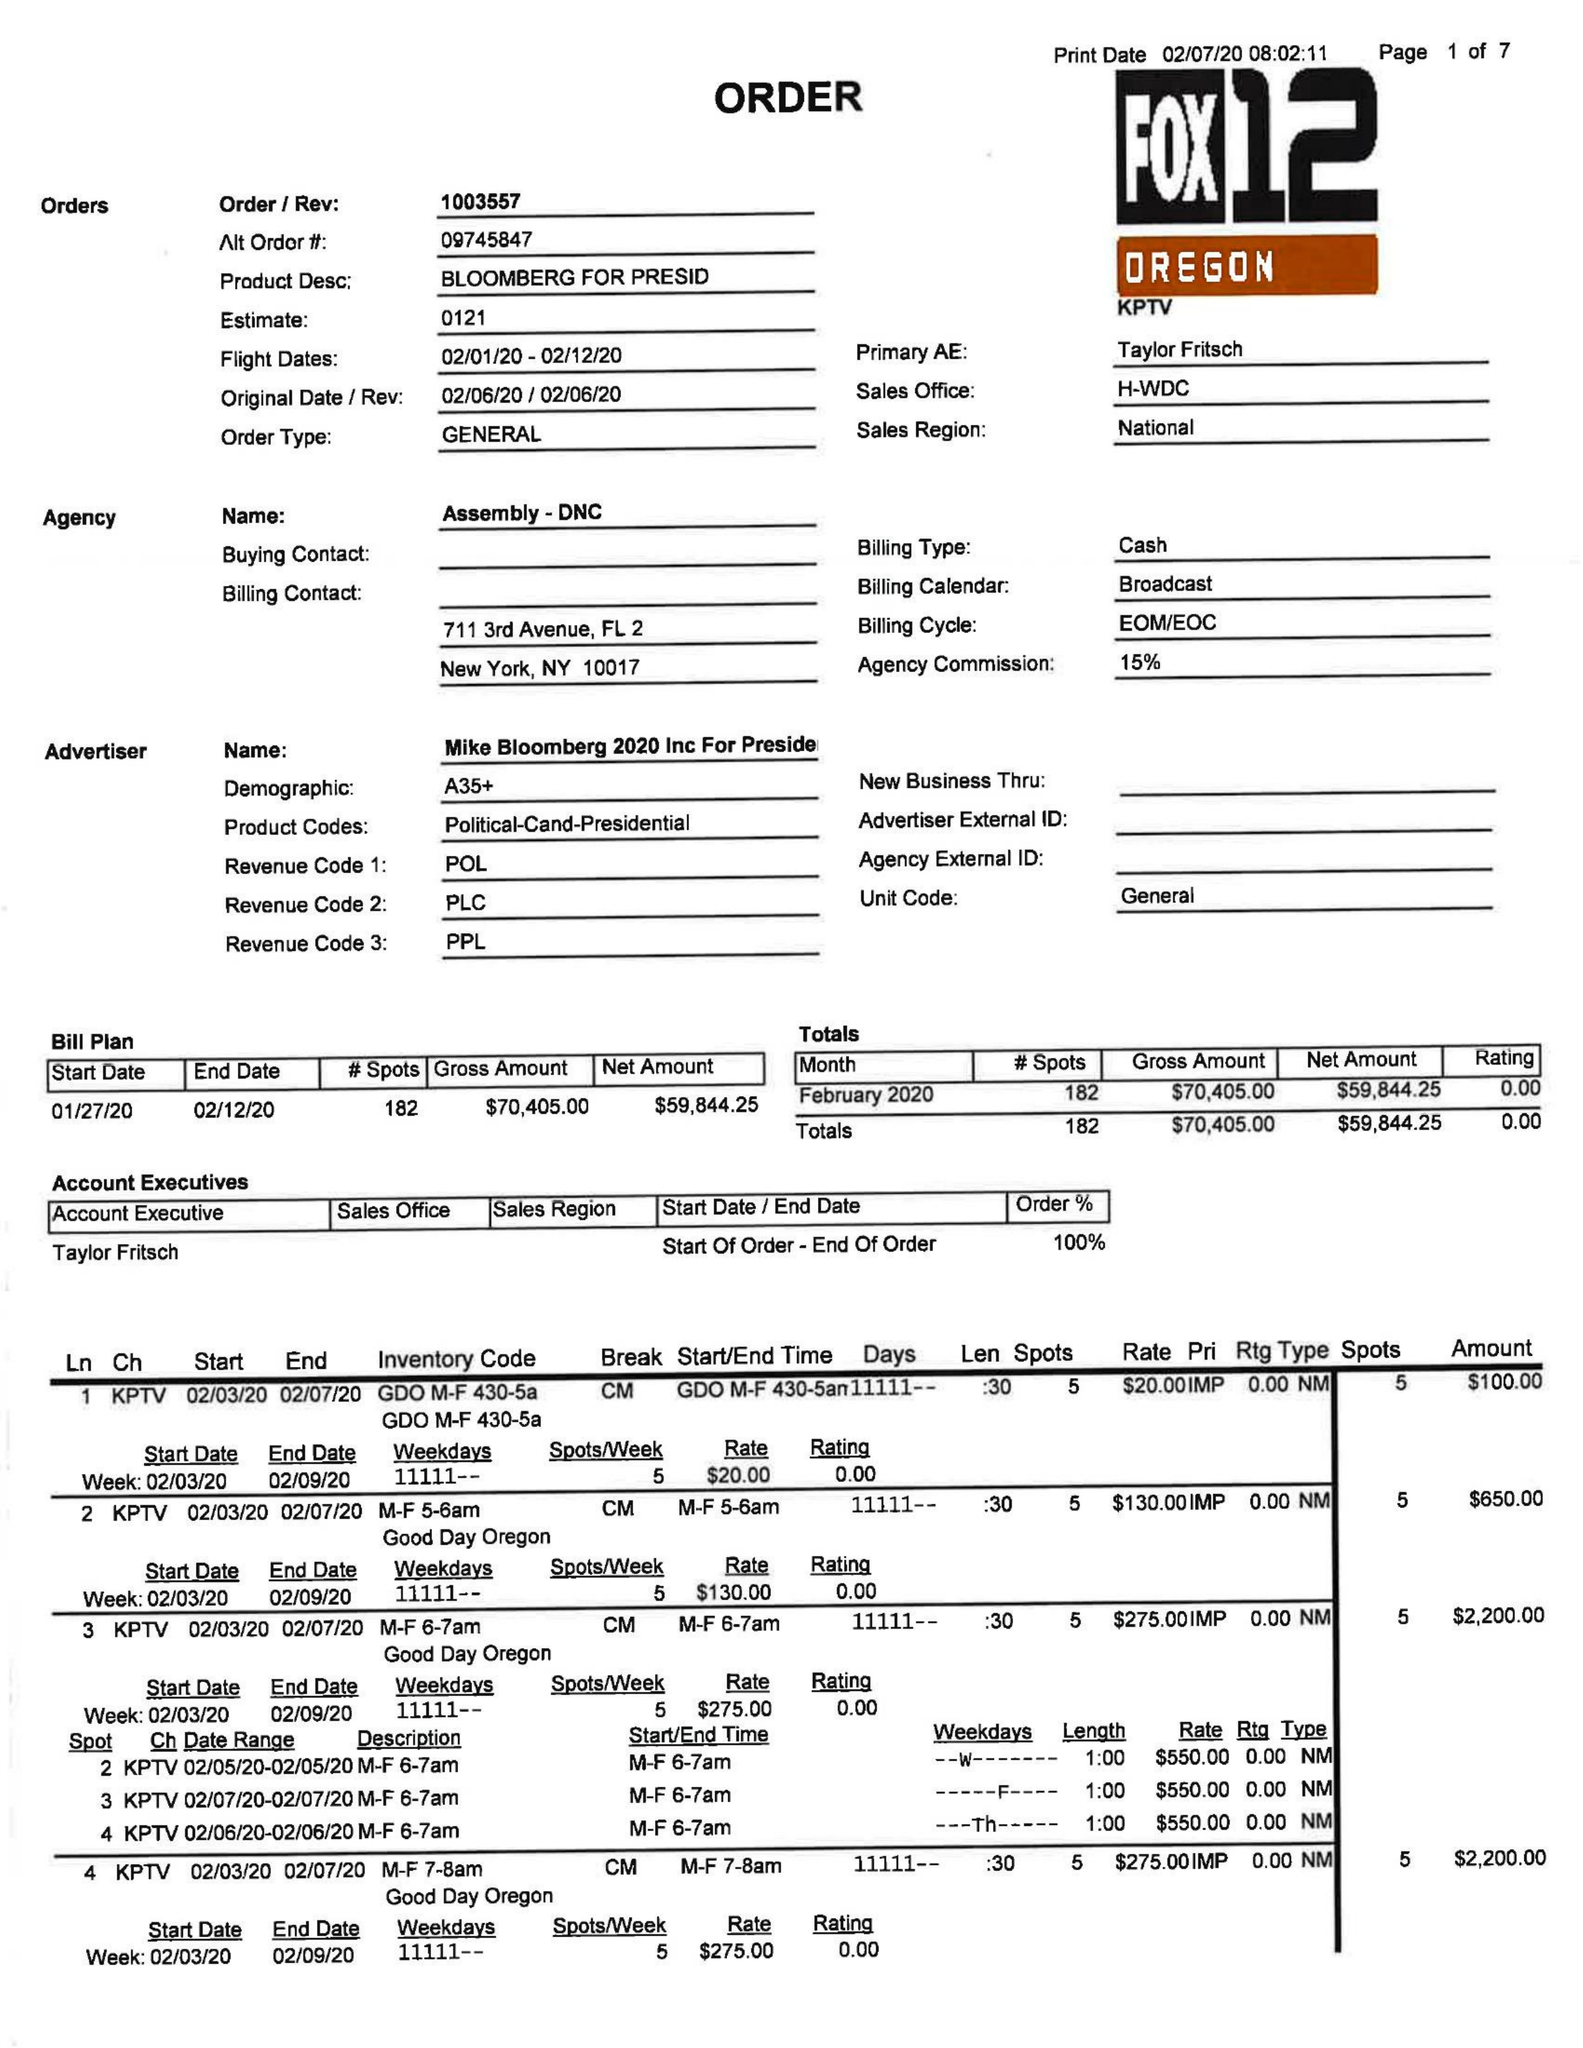What is the value for the flight_to?
Answer the question using a single word or phrase. 02/12/20 